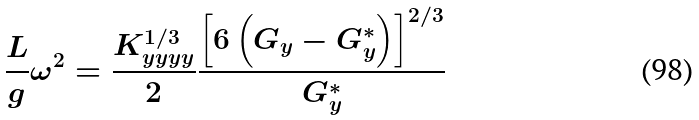<formula> <loc_0><loc_0><loc_500><loc_500>\frac { L } { g } \omega ^ { 2 } = \frac { K _ { y y y y } ^ { 1 / 3 } } { 2 } \frac { \left [ 6 \left ( G _ { y } - G _ { y } ^ { * } \right ) \right ] ^ { 2 / 3 } } { G _ { y } ^ { * } }</formula> 